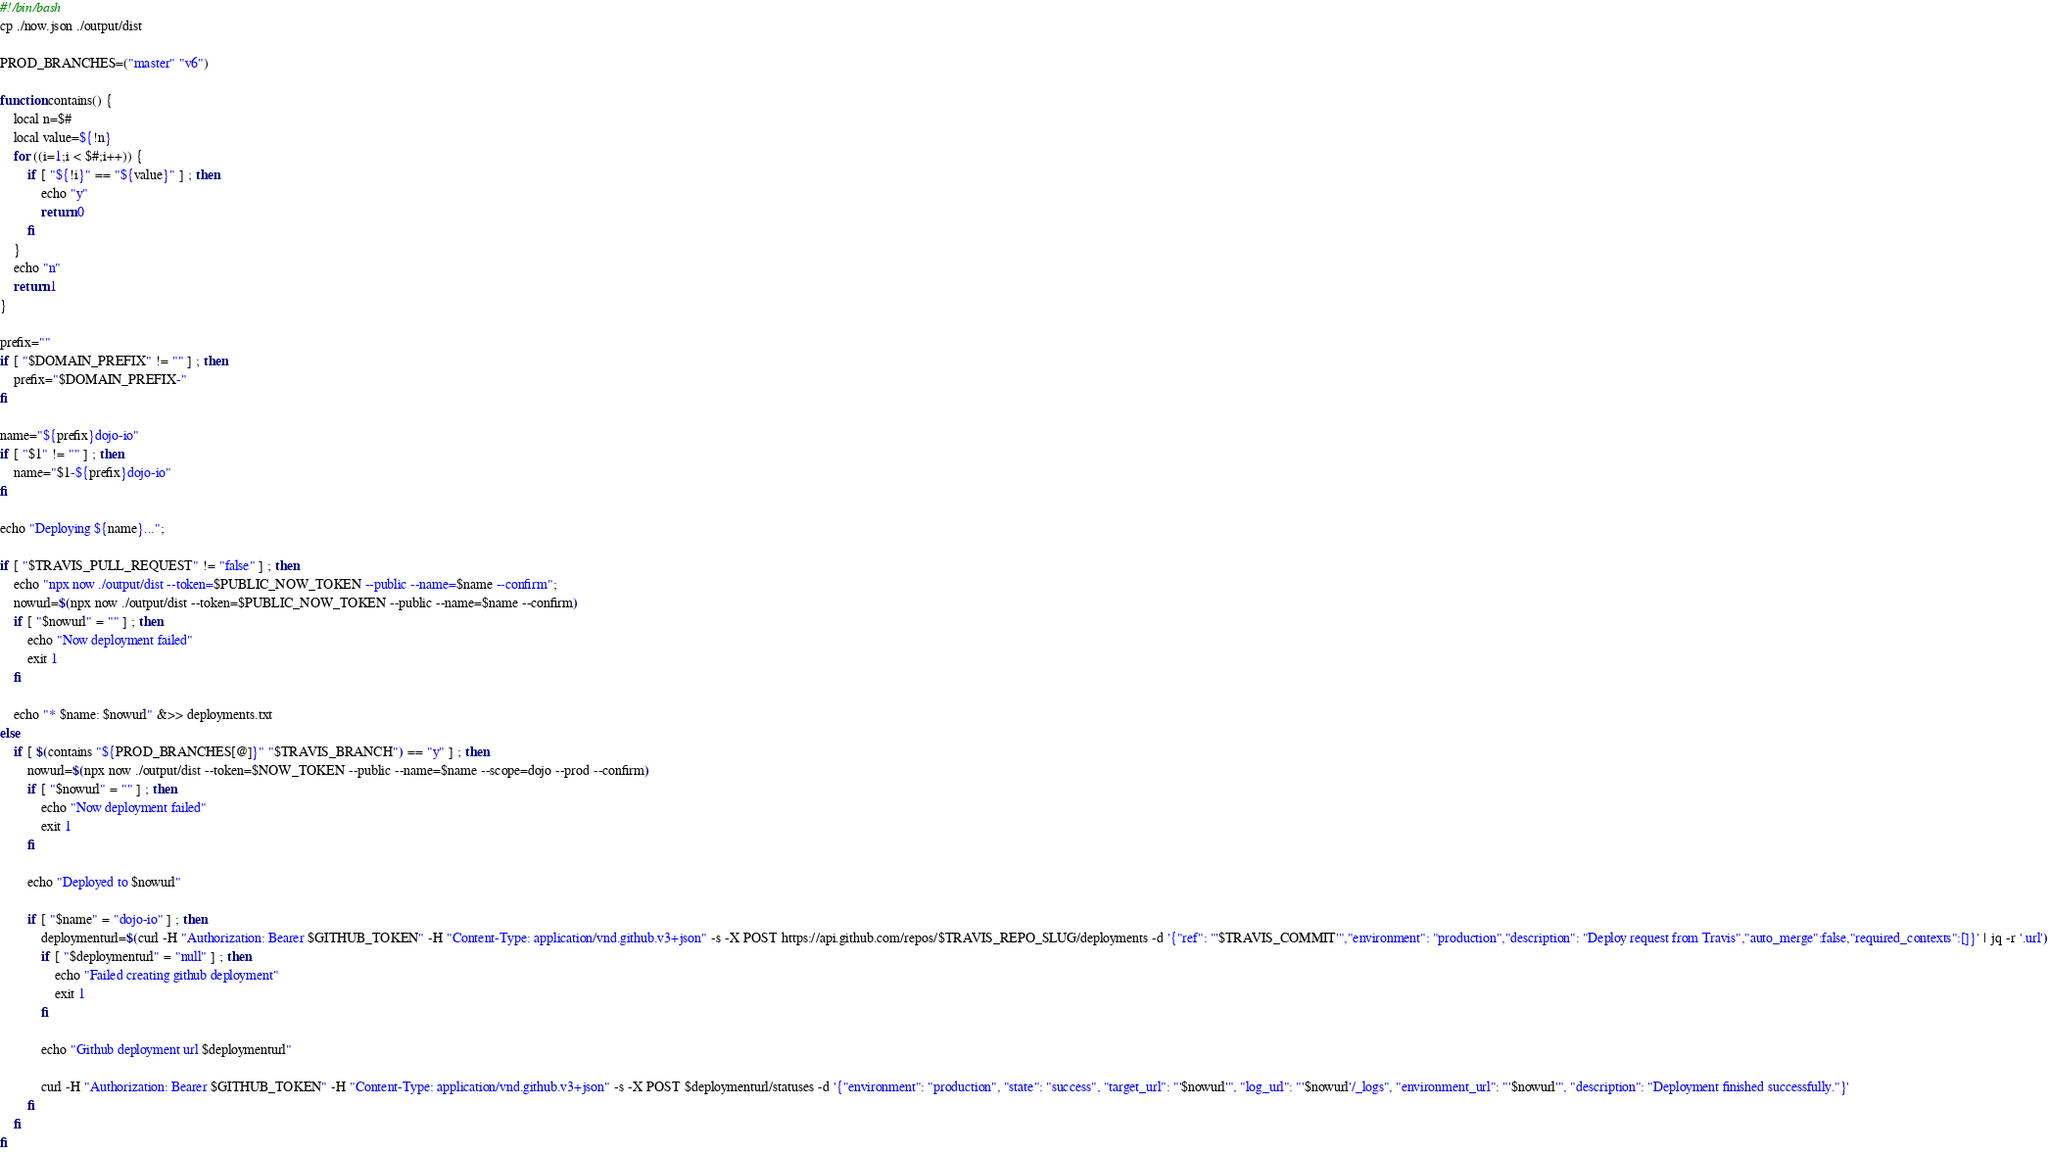Convert code to text. <code><loc_0><loc_0><loc_500><loc_500><_Bash_>#!/bin/bash
cp ./now.json ./output/dist

PROD_BRANCHES=("master" "v6")

function contains() {
	local n=$#
	local value=${!n}
	for ((i=1;i < $#;i++)) {
		if [ "${!i}" == "${value}" ] ; then
			echo "y"
			return 0
		fi
	}
	echo "n"
	return 1
}

prefix=""
if [ "$DOMAIN_PREFIX" != "" ] ; then
	prefix="$DOMAIN_PREFIX-"
fi

name="${prefix}dojo-io"
if [ "$1" != "" ] ; then
	name="$1-${prefix}dojo-io"
fi

echo "Deploying ${name}...";

if [ "$TRAVIS_PULL_REQUEST" != "false" ] ; then
	echo "npx now ./output/dist --token=$PUBLIC_NOW_TOKEN --public --name=$name --confirm";
	nowurl=$(npx now ./output/dist --token=$PUBLIC_NOW_TOKEN --public --name=$name --confirm)
	if [ "$nowurl" = "" ] ; then
		echo "Now deployment failed"
		exit 1
	fi

	echo "* $name: $nowurl" &>> deployments.txt
else
	if [ $(contains "${PROD_BRANCHES[@]}" "$TRAVIS_BRANCH") == "y" ] ; then
		nowurl=$(npx now ./output/dist --token=$NOW_TOKEN --public --name=$name --scope=dojo --prod --confirm)
		if [ "$nowurl" = "" ] ; then
			echo "Now deployment failed"
			exit 1
		fi

		echo "Deployed to $nowurl"

		if [ "$name" = "dojo-io" ] ; then
			deploymenturl=$(curl -H "Authorization: Bearer $GITHUB_TOKEN" -H "Content-Type: application/vnd.github.v3+json" -s -X POST https://api.github.com/repos/$TRAVIS_REPO_SLUG/deployments -d '{"ref": "'$TRAVIS_COMMIT'","environment": "production","description": "Deploy request from Travis","auto_merge":false,"required_contexts":[]}' | jq -r '.url')
			if [ "$deploymenturl" = "null" ] ; then
				echo "Failed creating github deployment"
				exit 1
			fi

			echo "Github deployment url $deploymenturl"

			curl -H "Authorization: Bearer $GITHUB_TOKEN" -H "Content-Type: application/vnd.github.v3+json" -s -X POST $deploymenturl/statuses -d '{"environment": "production", "state": "success", "target_url": "'$nowurl'", "log_url": "'$nowurl'/_logs", "environment_url": "'$nowurl'", "description": "Deployment finished successfully."}'
		fi
	fi
fi
</code> 